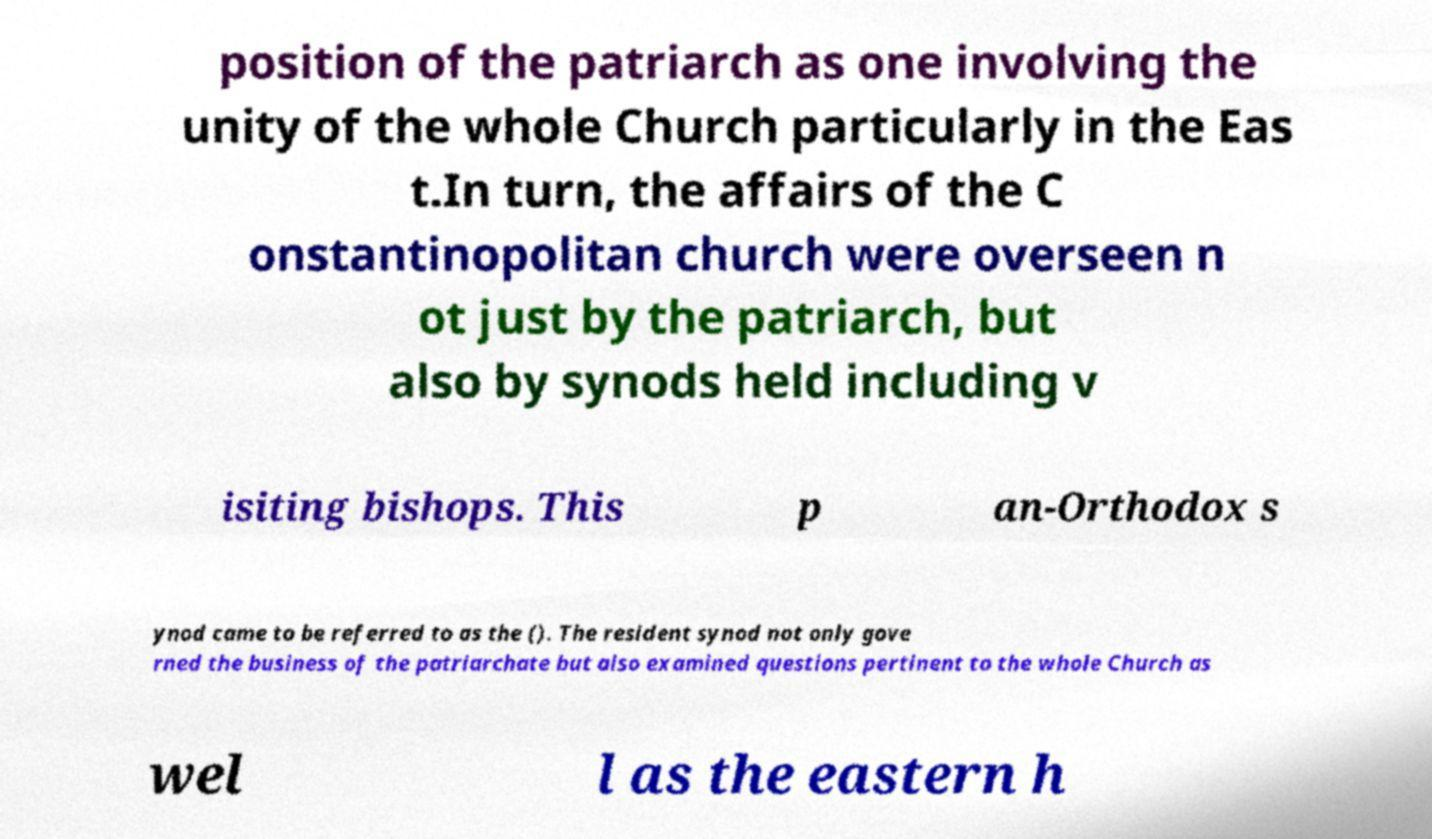Can you accurately transcribe the text from the provided image for me? position of the patriarch as one involving the unity of the whole Church particularly in the Eas t.In turn, the affairs of the C onstantinopolitan church were overseen n ot just by the patriarch, but also by synods held including v isiting bishops. This p an-Orthodox s ynod came to be referred to as the (). The resident synod not only gove rned the business of the patriarchate but also examined questions pertinent to the whole Church as wel l as the eastern h 